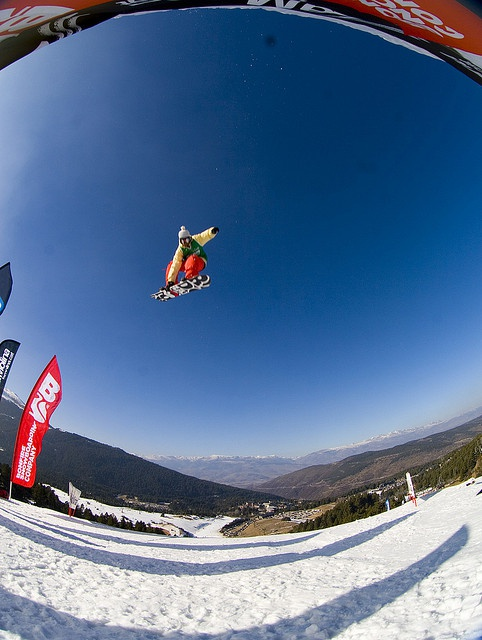Describe the objects in this image and their specific colors. I can see people in purple, black, blue, and maroon tones and snowboard in purple, black, darkgray, gray, and lightgray tones in this image. 